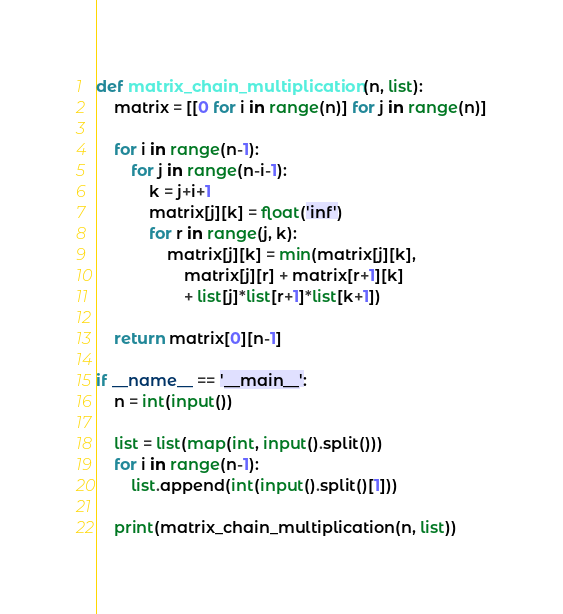<code> <loc_0><loc_0><loc_500><loc_500><_Python_>def matrix_chain_multiplication(n, list):
    matrix = [[0 for i in range(n)] for j in range(n)]

    for i in range(n-1):
        for j in range(n-i-1):
            k = j+i+1
            matrix[j][k] = float('inf')
            for r in range(j, k):
                matrix[j][k] = min(matrix[j][k],
                    matrix[j][r] + matrix[r+1][k]
                    + list[j]*list[r+1]*list[k+1])

    return matrix[0][n-1]

if __name__ == '__main__':
    n = int(input())

    list = list(map(int, input().split()))
    for i in range(n-1):
        list.append(int(input().split()[1]))

    print(matrix_chain_multiplication(n, list))</code> 